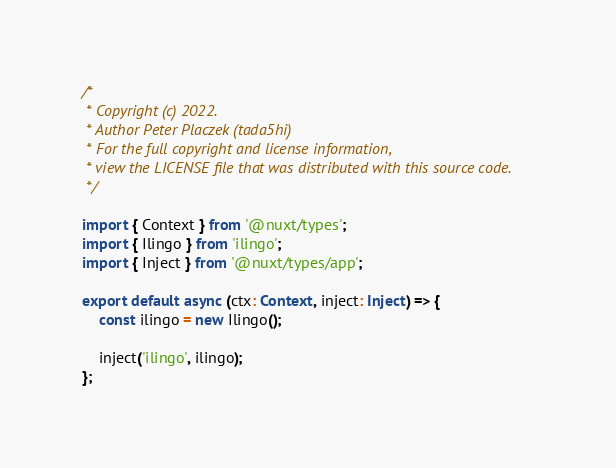<code> <loc_0><loc_0><loc_500><loc_500><_TypeScript_>/*
 * Copyright (c) 2022.
 * Author Peter Placzek (tada5hi)
 * For the full copyright and license information,
 * view the LICENSE file that was distributed with this source code.
 */

import { Context } from '@nuxt/types';
import { Ilingo } from 'ilingo';
import { Inject } from '@nuxt/types/app';

export default async (ctx: Context, inject: Inject) => {
    const ilingo = new Ilingo();

    inject('ilingo', ilingo);
};
</code> 